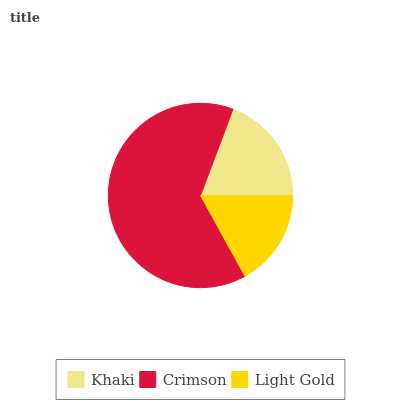Is Light Gold the minimum?
Answer yes or no. Yes. Is Crimson the maximum?
Answer yes or no. Yes. Is Crimson the minimum?
Answer yes or no. No. Is Light Gold the maximum?
Answer yes or no. No. Is Crimson greater than Light Gold?
Answer yes or no. Yes. Is Light Gold less than Crimson?
Answer yes or no. Yes. Is Light Gold greater than Crimson?
Answer yes or no. No. Is Crimson less than Light Gold?
Answer yes or no. No. Is Khaki the high median?
Answer yes or no. Yes. Is Khaki the low median?
Answer yes or no. Yes. Is Light Gold the high median?
Answer yes or no. No. Is Crimson the low median?
Answer yes or no. No. 